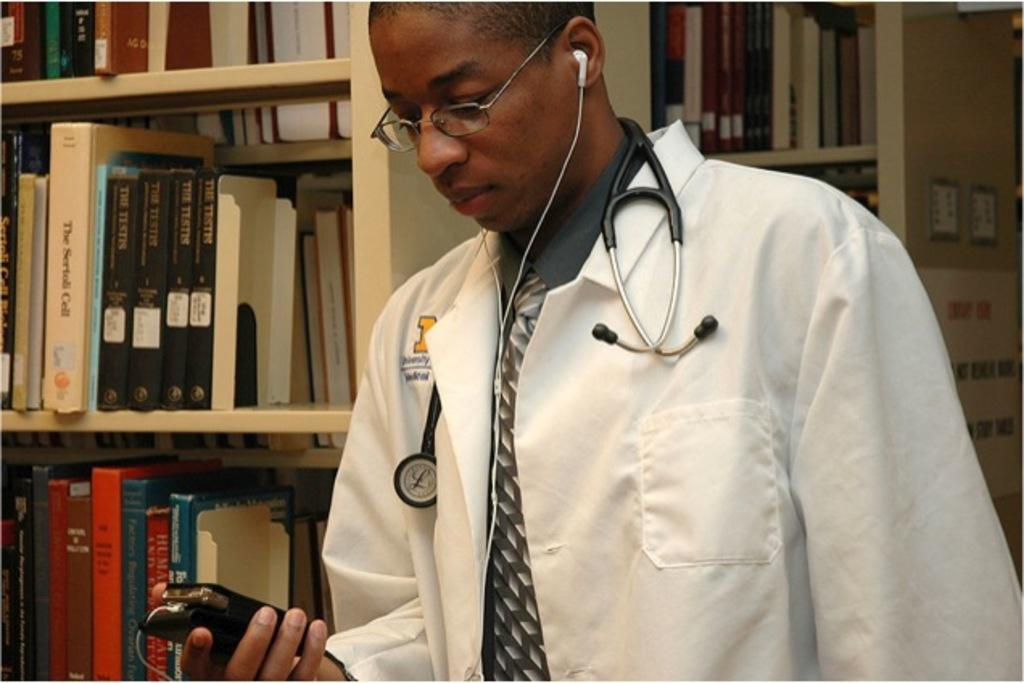What is the person in the image wearing? The person is wearing a doctor's coat and a stethoscope. What might indicate the person's profession in the image? The doctor's coat and stethoscope suggest that the person is a medical professional, likely a doctor. What is the person wearing in their ears? The person has earphones in their ears. What can be seen in the background of the image? There are books on racks in the background of the image. What type of hammer is the person using in the image? There is no hammer present in the image. Is the person playing baseball in the image? There is no indication of baseball or any related activity in the image. 